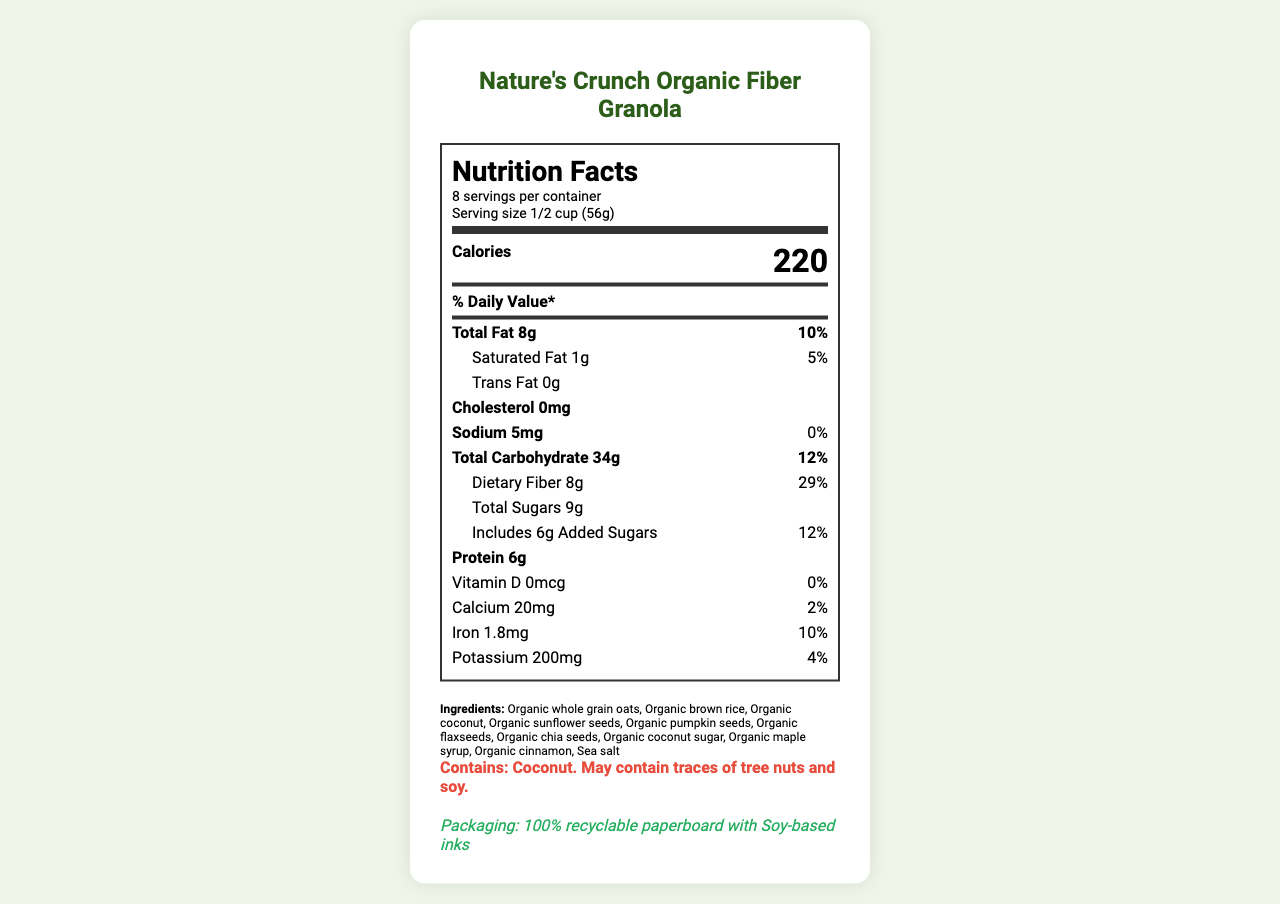what is the serving size? The serving size is listed in the top part of the Nutrition Facts section under "Serving size".
Answer: 1/2 cup (56g) how many calories are there per serving? The number of calories per serving is shown prominently in the Nutrition Facts section as "Calories 220".
Answer: 220 what is the amount of dietary fiber in one serving? The amount of dietary fiber is mentioned under the "Total Carbohydrate" entry as "Dietary Fiber 8g".
Answer: 8g how much added sugar is there in this granola? The amount of added sugars is indicated as "Includes 6g Added Sugars".
Answer: 6g what is the daily value percentage of dietary fiber? The daily value percentage for dietary fiber is listed as "Dietary Fiber 29%" under the "Total Carbohydrate" entry.
Answer: 29% how many grams of protein are in one serving? The amount of protein per serving is listed under the "Protein" entry as "6g".
Answer: 6g what natural sweeteners are used in the granola? The ingredients list mentions "Organic coconut sugar" and "Organic maple syrup" as sweeteners.
Answer: Organic coconut sugar and organic maple syrup what is the total fat content and its daily value percentage? A. 8g, 10% B. 5g, 8% C. 10g, 12% The total fat content is "8g" and its daily value percentage is "10%".
Answer: A what is the amount of sodium in one serving? A. 0mg B. 5mg C. 10mg The amount of sodium in one serving is listed as "Sodium 5mg".
Answer: B does this product contain cholesterol? The document lists "Cholesterol 0mg".
Answer: No is the packaging environmentally friendly? The packaging notes mention 100% recyclable paperboard and soy-based inks, indicating eco-friendly packaging.
Answer: Yes summarize the main features of the granola based on the document. The summary should capture the main nutritional features, packaging details, and overall philosophy of the product.
Answer: Nature's Crunch Organic Fiber Granola is an organic product high in dietary fiber (8g per serving) and uses natural sweeteners such as organic coconut sugar and organic maple syrup. It contains 220 calories per serving, with 6g of protein, 8g of total fat, and no cholesterol. The packaging is environmentally friendly, made from 100% recyclable paperboard and printed with soy-based inks. what is the source of omega-3 fatty acids in the granola? The document mentions that the granola is "rich in omega-3 fatty acids" but does not specify the exact ingredient sources for these fatty acids.
Answer: Not enough information 